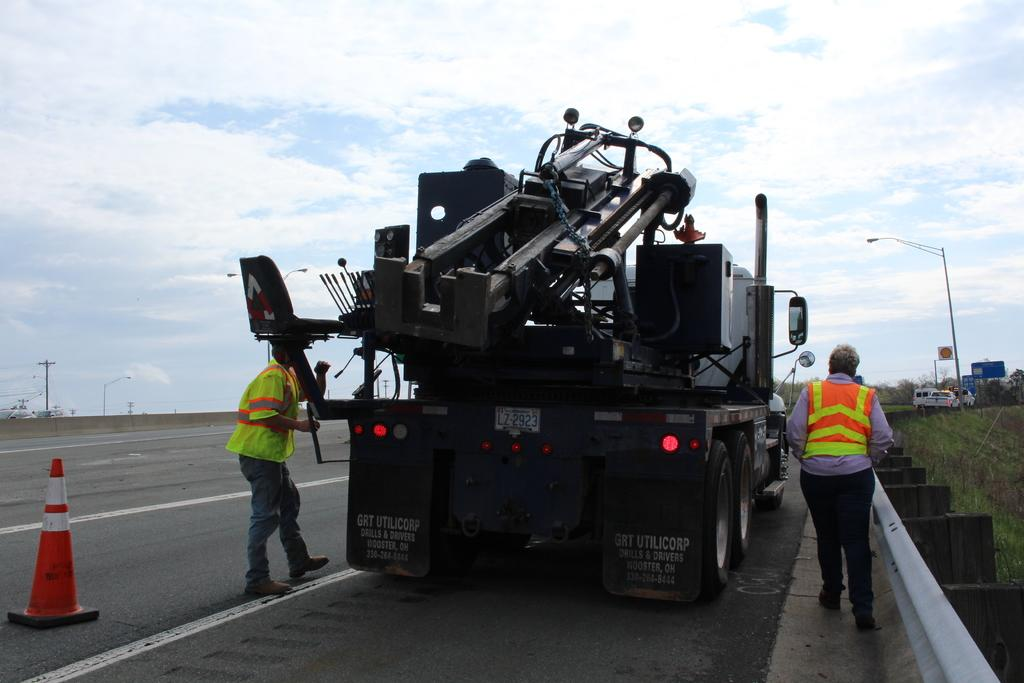What can be seen on the road in the image? There are vehicles on the road in the image. Are there any people present in the image? Yes, there are people in the image. What object can be seen on the left side of the image? There is a traffic cone on the left side of the image. What can be seen in the background of the image? There are poles, boards, and the sky visible in the background of the image. What type of school can be seen in the image? There is no school present in the image. What cast is performing on the boards in the background of the image? There is no cast or performance present in the image; only poles, boards, and the sky are visible in the background. 